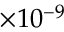Convert formula to latex. <formula><loc_0><loc_0><loc_500><loc_500>\times 1 0 ^ { - 9 }</formula> 